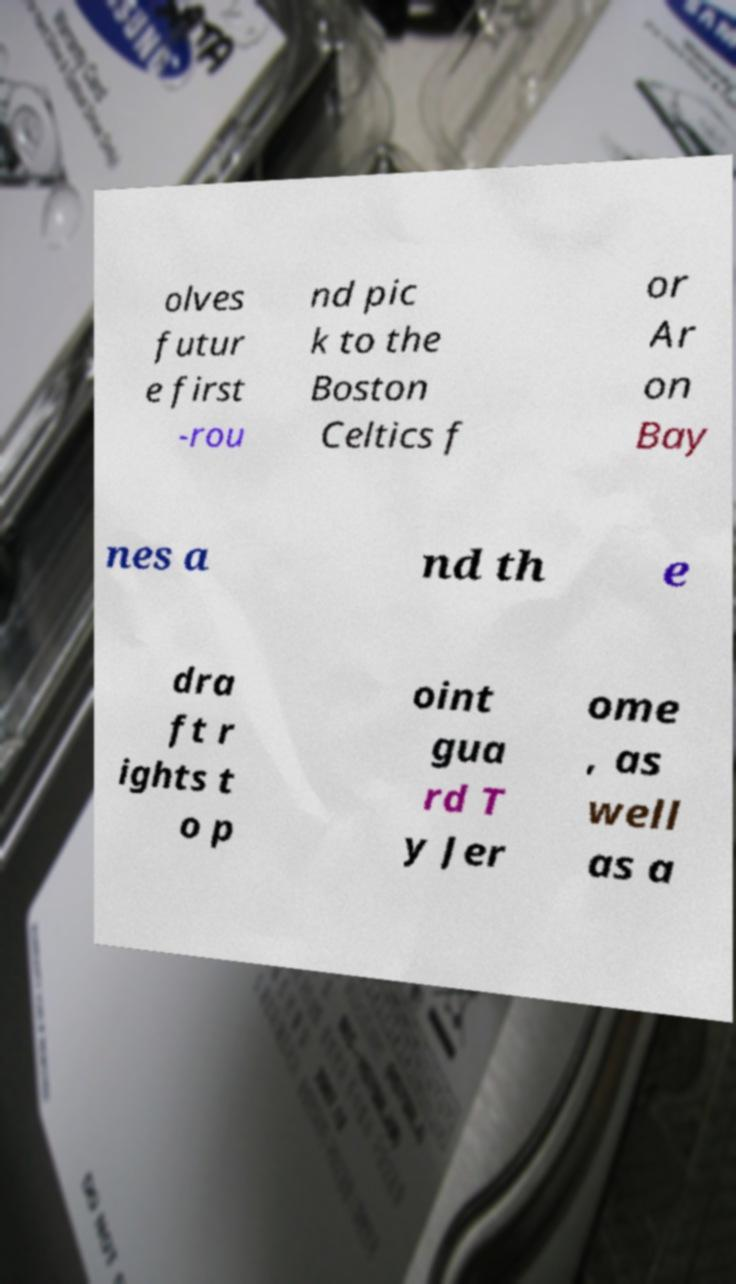I need the written content from this picture converted into text. Can you do that? olves futur e first -rou nd pic k to the Boston Celtics f or Ar on Bay nes a nd th e dra ft r ights t o p oint gua rd T y Jer ome , as well as a 